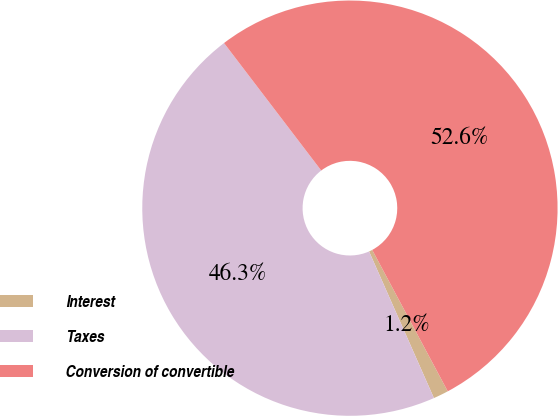Convert chart to OTSL. <chart><loc_0><loc_0><loc_500><loc_500><pie_chart><fcel>Interest<fcel>Taxes<fcel>Conversion of convertible<nl><fcel>1.18%<fcel>46.26%<fcel>52.56%<nl></chart> 